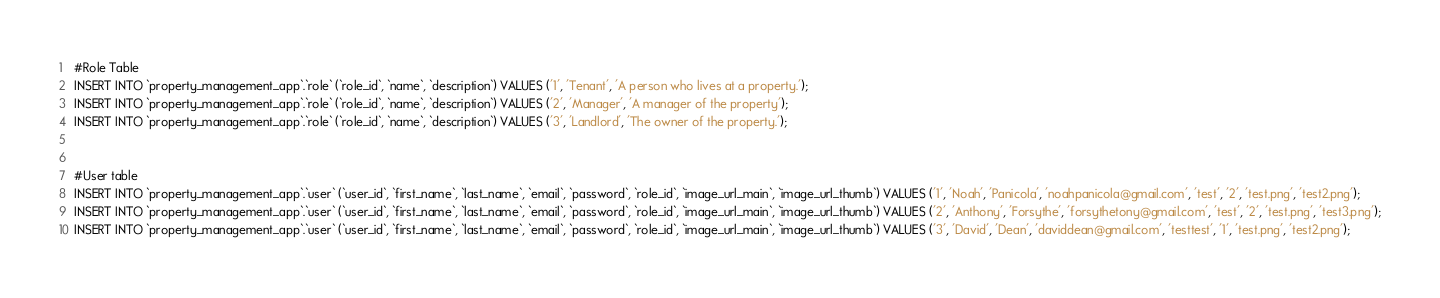Convert code to text. <code><loc_0><loc_0><loc_500><loc_500><_SQL_>#Role Table
INSERT INTO `property_management_app`.`role` (`role_id`, `name`, `description`) VALUES ('1', 'Tenant', 'A person who lives at a property.');
INSERT INTO `property_management_app`.`role` (`role_id`, `name`, `description`) VALUES ('2', 'Manager', 'A manager of the property');
INSERT INTO `property_management_app`.`role` (`role_id`, `name`, `description`) VALUES ('3', 'Landlord', 'The owner of the property.');


#User table
INSERT INTO `property_management_app`.`user` (`user_id`, `first_name`, `last_name`, `email`, `password`, `role_id`, `image_url_main`, `image_url_thumb`) VALUES ('1', 'Noah', 'Panicola', 'noahpanicola@gmail.com', 'test', '2', 'test.png', 'test2.png');
INSERT INTO `property_management_app`.`user` (`user_id`, `first_name`, `last_name`, `email`, `password`, `role_id`, `image_url_main`, `image_url_thumb`) VALUES ('2', 'Anthony', 'Forsythe', 'forsythetony@gmail.com', 'test', '2', 'test.png', 'test3.png');
INSERT INTO `property_management_app`.`user` (`user_id`, `first_name`, `last_name`, `email`, `password`, `role_id`, `image_url_main`, `image_url_thumb`) VALUES ('3', 'David', 'Dean', 'daviddean@gmail.com', 'testtest', '1', 'test.png', 'test2.png');</code> 